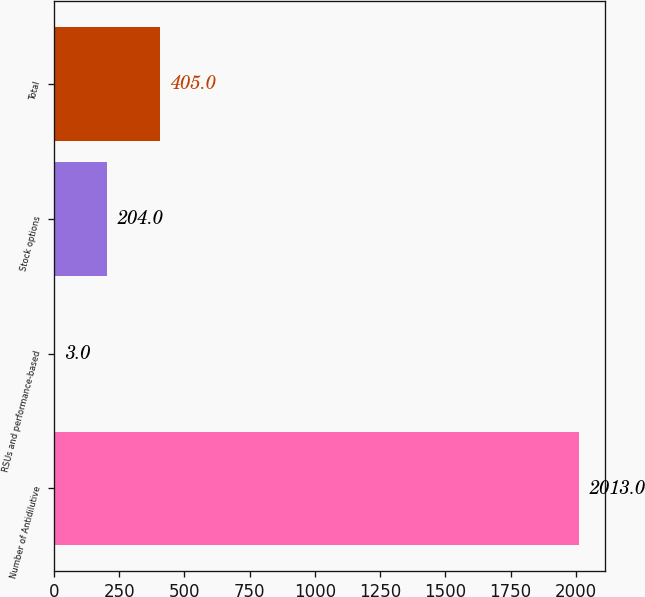<chart> <loc_0><loc_0><loc_500><loc_500><bar_chart><fcel>Number of Antidilutive<fcel>RSUs and performance-based<fcel>Stock options<fcel>Total<nl><fcel>2013<fcel>3<fcel>204<fcel>405<nl></chart> 